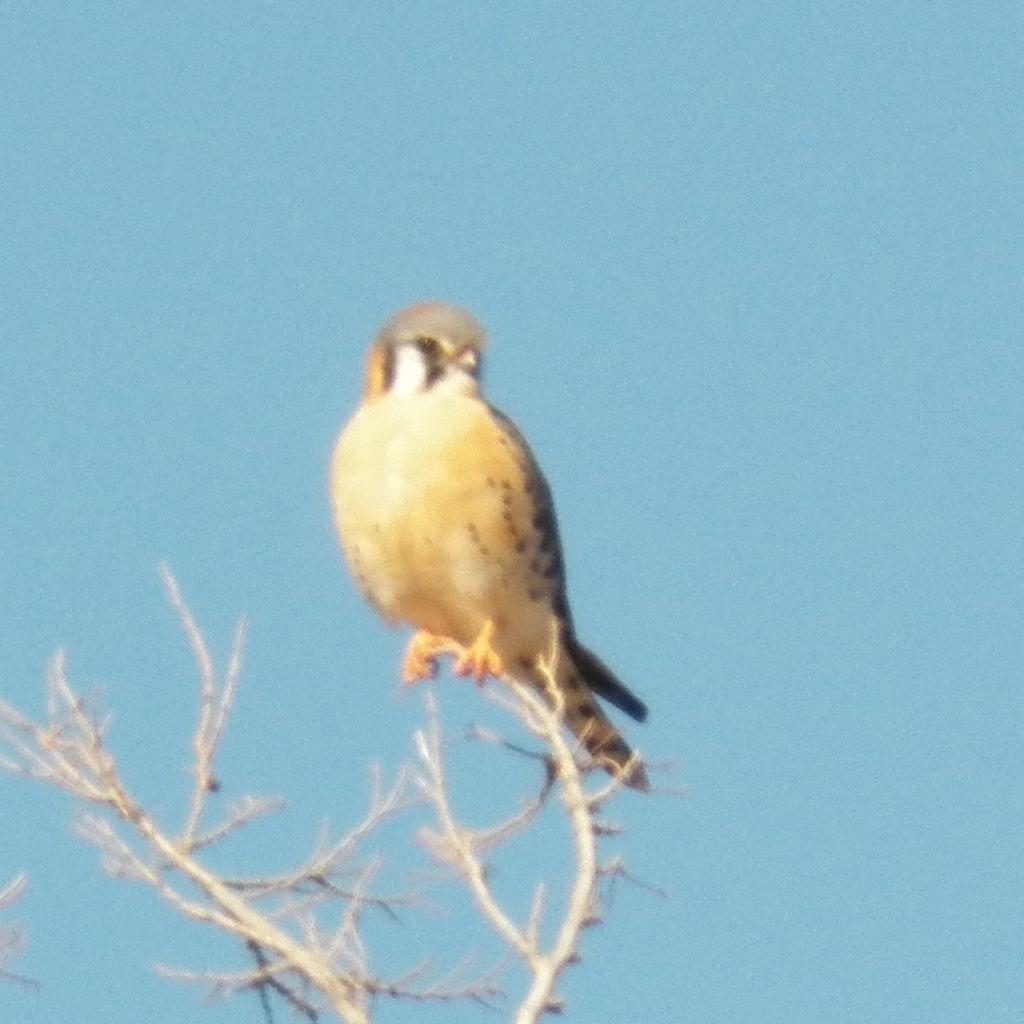Could you give a brief overview of what you see in this image? In this image we can see a bird on the branch of a tree. 